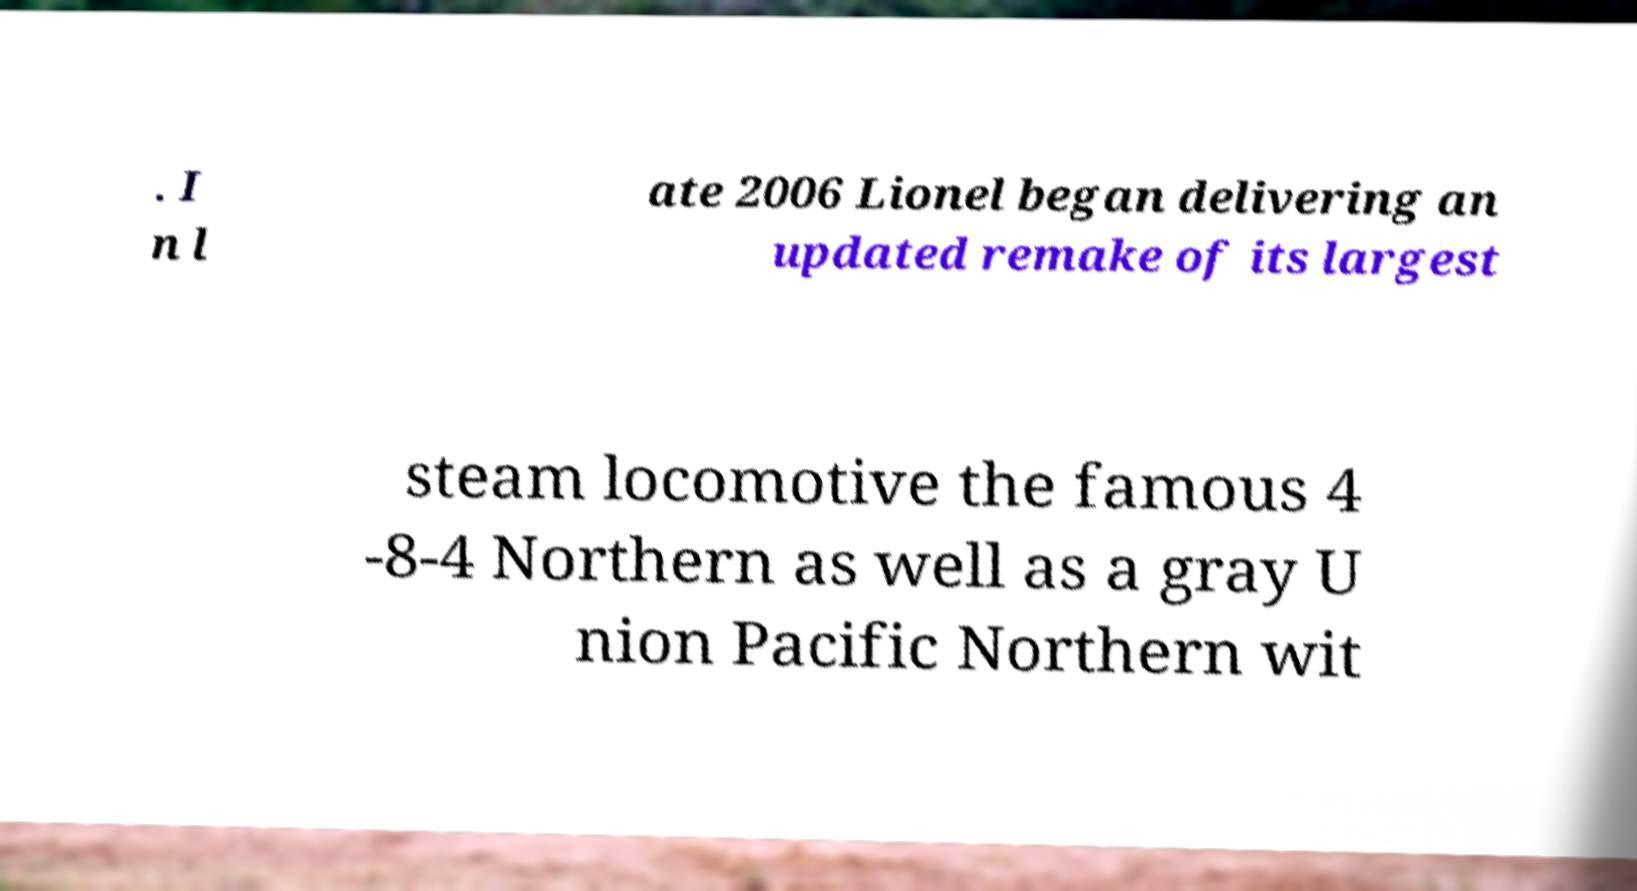What messages or text are displayed in this image? I need them in a readable, typed format. . I n l ate 2006 Lionel began delivering an updated remake of its largest steam locomotive the famous 4 -8-4 Northern as well as a gray U nion Pacific Northern wit 